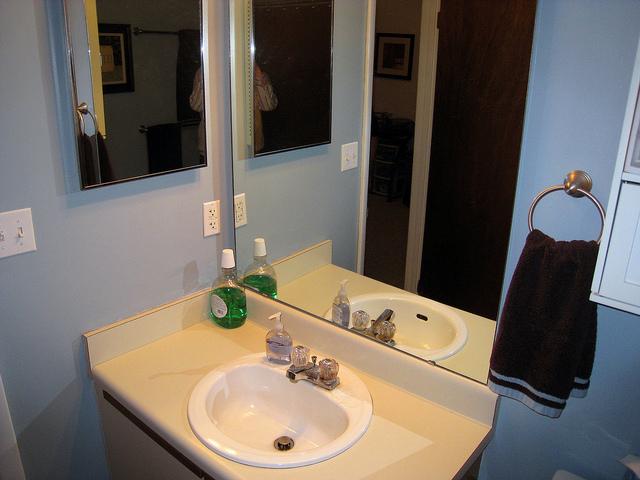Where is the person standing who is taking this picture?
Write a very short answer. Bathroom. What is the green bottle used for?
Give a very brief answer. Mouthwash. How many picture frames are in this picture?
Keep it brief. 2. How many knobs are on the faucet?
Concise answer only. 2. 